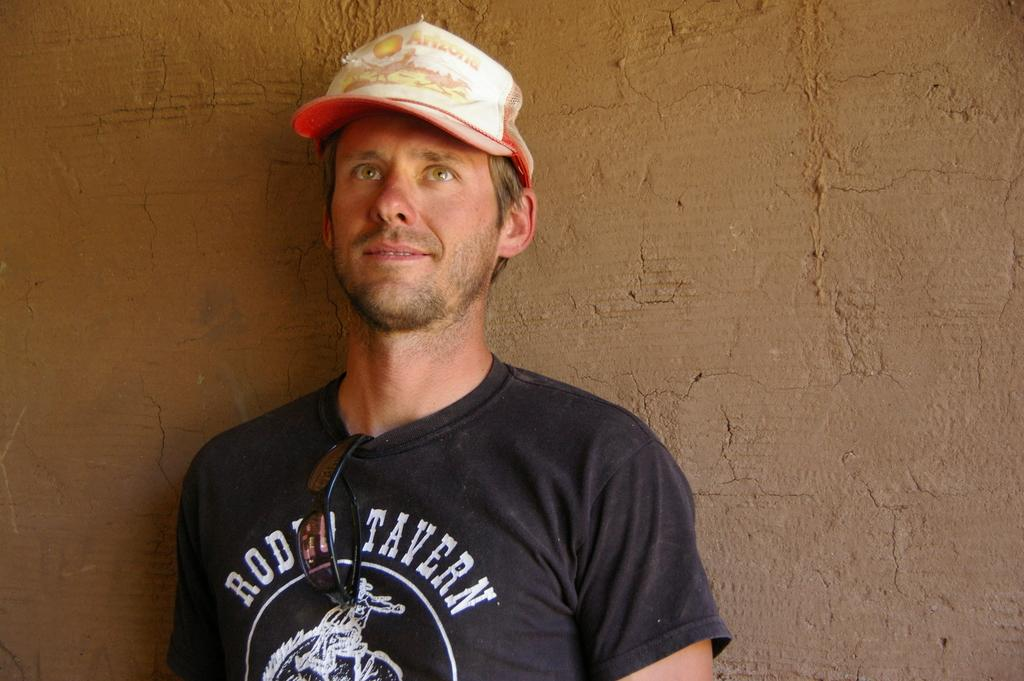<image>
Describe the image concisely. A man poses for a photo in an Arizona hat and Rodeo Tavern t-shirt. 